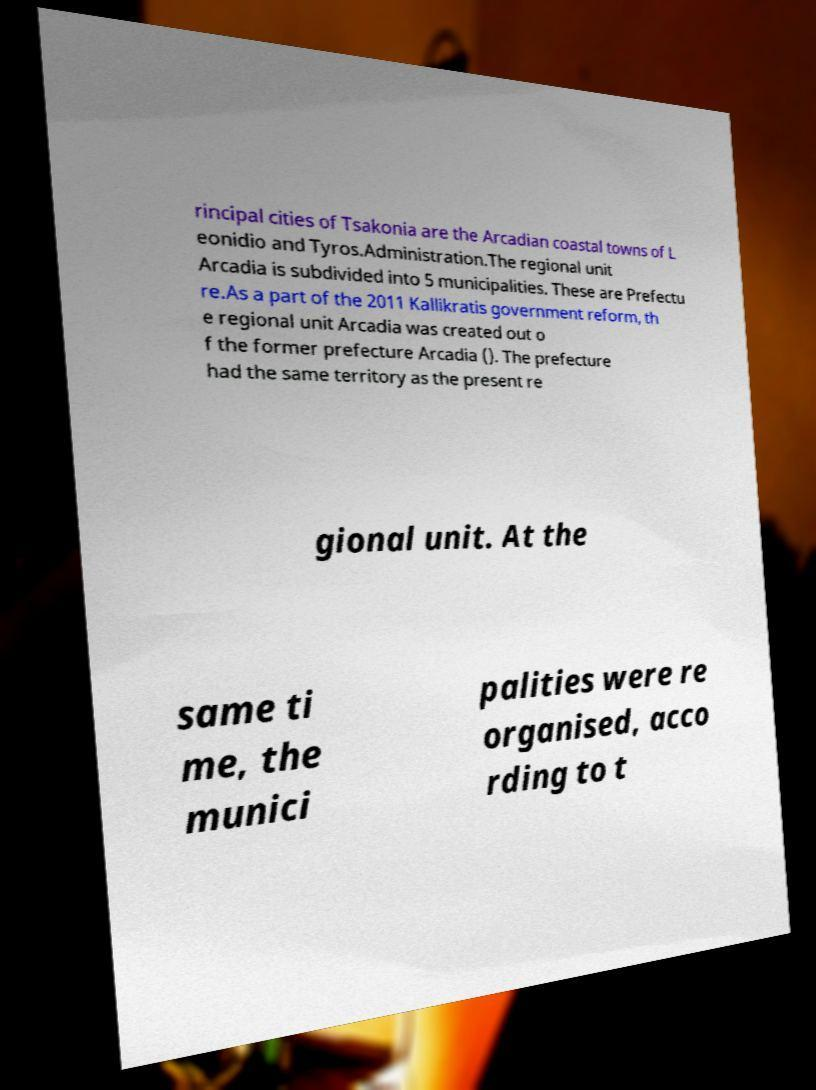Please read and relay the text visible in this image. What does it say? rincipal cities of Tsakonia are the Arcadian coastal towns of L eonidio and Tyros.Administration.The regional unit Arcadia is subdivided into 5 municipalities. These are Prefectu re.As a part of the 2011 Kallikratis government reform, th e regional unit Arcadia was created out o f the former prefecture Arcadia (). The prefecture had the same territory as the present re gional unit. At the same ti me, the munici palities were re organised, acco rding to t 